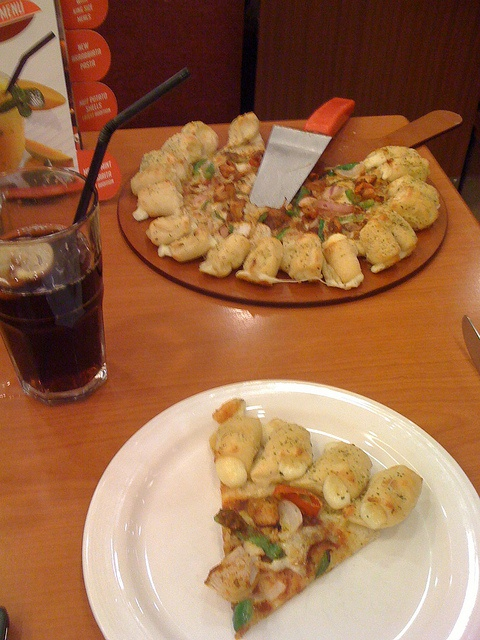Describe the objects in this image and their specific colors. I can see dining table in brown, tan, maroon, and salmon tones, pizza in brown, tan, and maroon tones, pizza in brown, tan, and olive tones, cup in brown, black, maroon, and gray tones, and knife in brown, darkgray, maroon, and red tones in this image. 